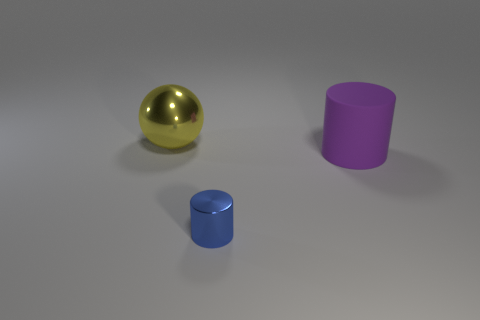Can you speculate on the materials these objects might be made of? Based on their appearance, the golden sphere may be metallic, reflecting its surroundings with a smooth and shiny surface. The blue and purple objects look matte, possibly made of a plastic or painted material, largely due to their less reflective surfaces. How can you tell the difference in materials? The key indicators are reflectivity and texture. Metallic surfaces often have high reflectivity and smooth textures. In contrast, plastic materials might show color uniformly and reflect light less intensely. 